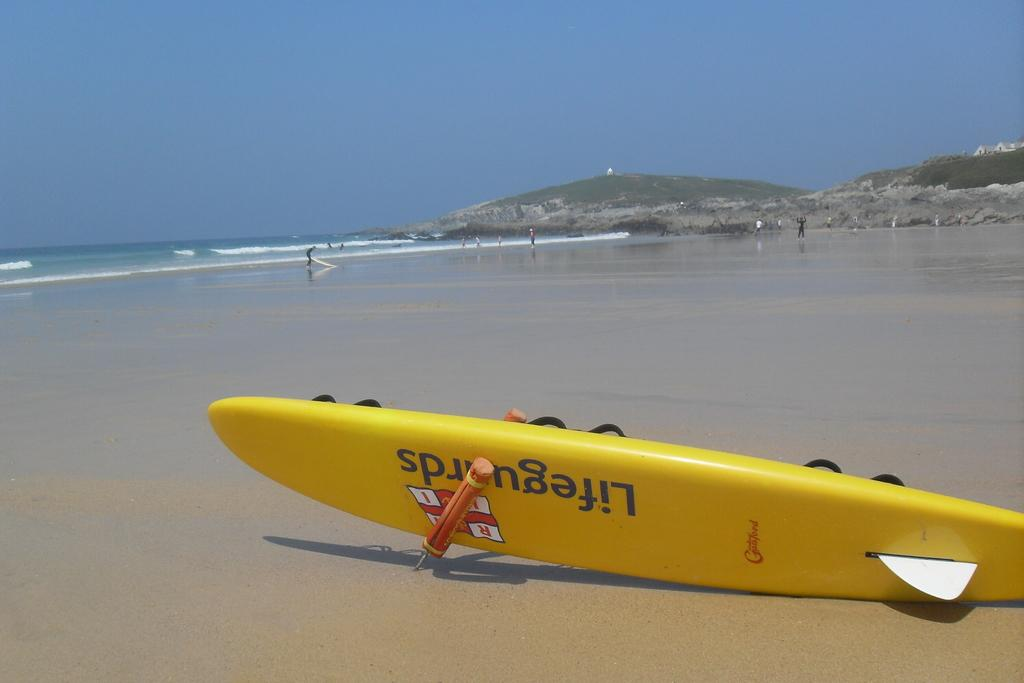<image>
Offer a succinct explanation of the picture presented. A picture of the beach with a yellow Lifeguard raft on its side 